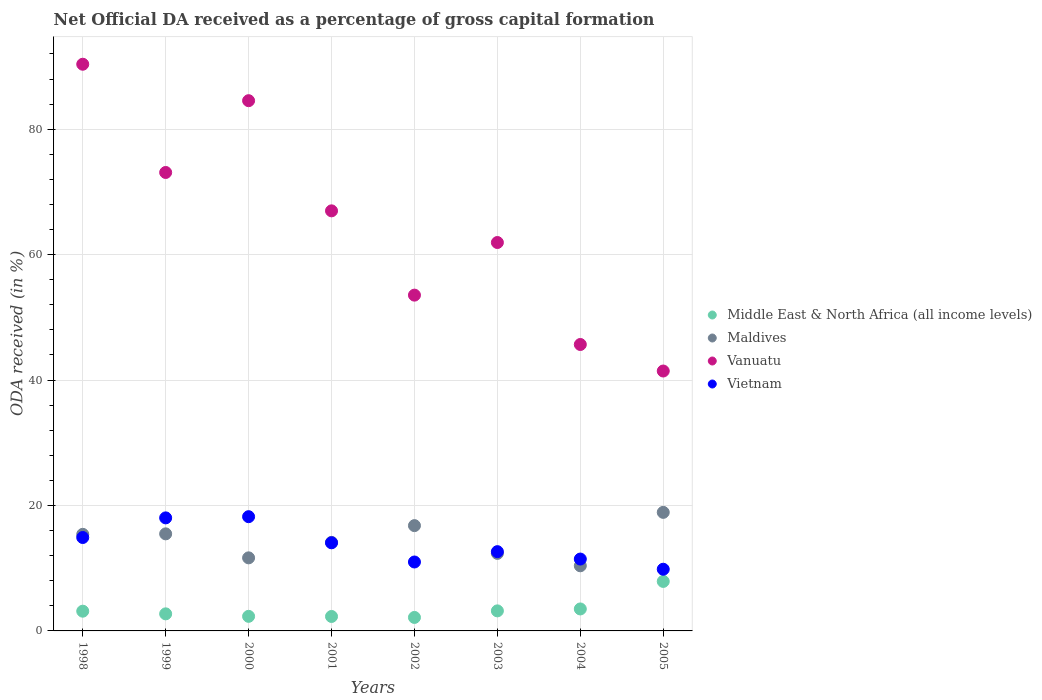Is the number of dotlines equal to the number of legend labels?
Provide a succinct answer. Yes. What is the net ODA received in Maldives in 2001?
Provide a succinct answer. 14.12. Across all years, what is the maximum net ODA received in Middle East & North Africa (all income levels)?
Your response must be concise. 7.89. Across all years, what is the minimum net ODA received in Vietnam?
Provide a short and direct response. 9.84. In which year was the net ODA received in Middle East & North Africa (all income levels) minimum?
Give a very brief answer. 2002. What is the total net ODA received in Maldives in the graph?
Keep it short and to the point. 115.09. What is the difference between the net ODA received in Vietnam in 2003 and that in 2004?
Provide a succinct answer. 1.18. What is the difference between the net ODA received in Middle East & North Africa (all income levels) in 2001 and the net ODA received in Maldives in 2005?
Your answer should be very brief. -16.6. What is the average net ODA received in Vietnam per year?
Make the answer very short. 13.76. In the year 2003, what is the difference between the net ODA received in Maldives and net ODA received in Vietnam?
Provide a succinct answer. -0.27. What is the ratio of the net ODA received in Vietnam in 1999 to that in 2005?
Keep it short and to the point. 1.83. Is the net ODA received in Maldives in 2000 less than that in 2005?
Provide a short and direct response. Yes. Is the difference between the net ODA received in Maldives in 2003 and 2005 greater than the difference between the net ODA received in Vietnam in 2003 and 2005?
Keep it short and to the point. No. What is the difference between the highest and the second highest net ODA received in Vietnam?
Offer a terse response. 0.19. What is the difference between the highest and the lowest net ODA received in Middle East & North Africa (all income levels)?
Make the answer very short. 5.74. In how many years, is the net ODA received in Maldives greater than the average net ODA received in Maldives taken over all years?
Your answer should be compact. 4. Is the sum of the net ODA received in Middle East & North Africa (all income levels) in 2001 and 2003 greater than the maximum net ODA received in Vanuatu across all years?
Your response must be concise. No. Is it the case that in every year, the sum of the net ODA received in Middle East & North Africa (all income levels) and net ODA received in Maldives  is greater than the sum of net ODA received in Vanuatu and net ODA received in Vietnam?
Offer a terse response. No. How many dotlines are there?
Provide a succinct answer. 4. How many years are there in the graph?
Provide a short and direct response. 8. Does the graph contain grids?
Your response must be concise. Yes. How are the legend labels stacked?
Offer a very short reply. Vertical. What is the title of the graph?
Offer a very short reply. Net Official DA received as a percentage of gross capital formation. Does "European Union" appear as one of the legend labels in the graph?
Keep it short and to the point. No. What is the label or title of the X-axis?
Make the answer very short. Years. What is the label or title of the Y-axis?
Make the answer very short. ODA received (in %). What is the ODA received (in %) in Middle East & North Africa (all income levels) in 1998?
Provide a short and direct response. 3.15. What is the ODA received (in %) of Maldives in 1998?
Provide a succinct answer. 15.4. What is the ODA received (in %) of Vanuatu in 1998?
Ensure brevity in your answer.  90.36. What is the ODA received (in %) of Vietnam in 1998?
Offer a very short reply. 14.89. What is the ODA received (in %) in Middle East & North Africa (all income levels) in 1999?
Your answer should be very brief. 2.72. What is the ODA received (in %) in Maldives in 1999?
Make the answer very short. 15.48. What is the ODA received (in %) of Vanuatu in 1999?
Provide a succinct answer. 73.1. What is the ODA received (in %) in Vietnam in 1999?
Your answer should be very brief. 18.03. What is the ODA received (in %) of Middle East & North Africa (all income levels) in 2000?
Provide a short and direct response. 2.32. What is the ODA received (in %) in Maldives in 2000?
Your answer should be compact. 11.65. What is the ODA received (in %) of Vanuatu in 2000?
Give a very brief answer. 84.55. What is the ODA received (in %) in Vietnam in 2000?
Offer a very short reply. 18.22. What is the ODA received (in %) in Middle East & North Africa (all income levels) in 2001?
Offer a terse response. 2.3. What is the ODA received (in %) in Maldives in 2001?
Your answer should be compact. 14.12. What is the ODA received (in %) of Vanuatu in 2001?
Give a very brief answer. 66.98. What is the ODA received (in %) of Vietnam in 2001?
Ensure brevity in your answer.  14.05. What is the ODA received (in %) in Middle East & North Africa (all income levels) in 2002?
Your answer should be very brief. 2.15. What is the ODA received (in %) in Maldives in 2002?
Offer a very short reply. 16.79. What is the ODA received (in %) in Vanuatu in 2002?
Give a very brief answer. 53.54. What is the ODA received (in %) of Vietnam in 2002?
Offer a terse response. 10.99. What is the ODA received (in %) in Middle East & North Africa (all income levels) in 2003?
Your answer should be compact. 3.2. What is the ODA received (in %) of Maldives in 2003?
Your answer should be very brief. 12.36. What is the ODA received (in %) of Vanuatu in 2003?
Offer a very short reply. 61.93. What is the ODA received (in %) of Vietnam in 2003?
Provide a succinct answer. 12.64. What is the ODA received (in %) of Middle East & North Africa (all income levels) in 2004?
Offer a very short reply. 3.5. What is the ODA received (in %) in Maldives in 2004?
Provide a short and direct response. 10.39. What is the ODA received (in %) in Vanuatu in 2004?
Your answer should be compact. 45.67. What is the ODA received (in %) of Vietnam in 2004?
Give a very brief answer. 11.46. What is the ODA received (in %) in Middle East & North Africa (all income levels) in 2005?
Your response must be concise. 7.89. What is the ODA received (in %) in Maldives in 2005?
Ensure brevity in your answer.  18.9. What is the ODA received (in %) in Vanuatu in 2005?
Provide a succinct answer. 41.44. What is the ODA received (in %) of Vietnam in 2005?
Offer a terse response. 9.84. Across all years, what is the maximum ODA received (in %) in Middle East & North Africa (all income levels)?
Give a very brief answer. 7.89. Across all years, what is the maximum ODA received (in %) of Maldives?
Make the answer very short. 18.9. Across all years, what is the maximum ODA received (in %) in Vanuatu?
Your answer should be compact. 90.36. Across all years, what is the maximum ODA received (in %) of Vietnam?
Ensure brevity in your answer.  18.22. Across all years, what is the minimum ODA received (in %) in Middle East & North Africa (all income levels)?
Your answer should be very brief. 2.15. Across all years, what is the minimum ODA received (in %) of Maldives?
Your answer should be compact. 10.39. Across all years, what is the minimum ODA received (in %) in Vanuatu?
Your answer should be very brief. 41.44. Across all years, what is the minimum ODA received (in %) in Vietnam?
Provide a succinct answer. 9.84. What is the total ODA received (in %) of Middle East & North Africa (all income levels) in the graph?
Your answer should be very brief. 27.24. What is the total ODA received (in %) of Maldives in the graph?
Provide a short and direct response. 115.09. What is the total ODA received (in %) of Vanuatu in the graph?
Make the answer very short. 517.6. What is the total ODA received (in %) in Vietnam in the graph?
Provide a short and direct response. 110.11. What is the difference between the ODA received (in %) in Middle East & North Africa (all income levels) in 1998 and that in 1999?
Offer a very short reply. 0.42. What is the difference between the ODA received (in %) in Maldives in 1998 and that in 1999?
Keep it short and to the point. -0.08. What is the difference between the ODA received (in %) in Vanuatu in 1998 and that in 1999?
Offer a very short reply. 17.26. What is the difference between the ODA received (in %) of Vietnam in 1998 and that in 1999?
Offer a very short reply. -3.13. What is the difference between the ODA received (in %) in Middle East & North Africa (all income levels) in 1998 and that in 2000?
Provide a short and direct response. 0.82. What is the difference between the ODA received (in %) of Maldives in 1998 and that in 2000?
Provide a succinct answer. 3.75. What is the difference between the ODA received (in %) of Vanuatu in 1998 and that in 2000?
Give a very brief answer. 5.81. What is the difference between the ODA received (in %) in Vietnam in 1998 and that in 2000?
Your answer should be very brief. -3.32. What is the difference between the ODA received (in %) in Middle East & North Africa (all income levels) in 1998 and that in 2001?
Offer a terse response. 0.84. What is the difference between the ODA received (in %) in Maldives in 1998 and that in 2001?
Give a very brief answer. 1.28. What is the difference between the ODA received (in %) of Vanuatu in 1998 and that in 2001?
Ensure brevity in your answer.  23.38. What is the difference between the ODA received (in %) in Vietnam in 1998 and that in 2001?
Provide a short and direct response. 0.84. What is the difference between the ODA received (in %) of Maldives in 1998 and that in 2002?
Your answer should be very brief. -1.39. What is the difference between the ODA received (in %) of Vanuatu in 1998 and that in 2002?
Provide a short and direct response. 36.82. What is the difference between the ODA received (in %) of Vietnam in 1998 and that in 2002?
Ensure brevity in your answer.  3.9. What is the difference between the ODA received (in %) in Middle East & North Africa (all income levels) in 1998 and that in 2003?
Your answer should be compact. -0.05. What is the difference between the ODA received (in %) in Maldives in 1998 and that in 2003?
Your answer should be compact. 3.04. What is the difference between the ODA received (in %) of Vanuatu in 1998 and that in 2003?
Your answer should be compact. 28.43. What is the difference between the ODA received (in %) in Vietnam in 1998 and that in 2003?
Offer a very short reply. 2.26. What is the difference between the ODA received (in %) of Middle East & North Africa (all income levels) in 1998 and that in 2004?
Offer a terse response. -0.36. What is the difference between the ODA received (in %) of Maldives in 1998 and that in 2004?
Offer a very short reply. 5.02. What is the difference between the ODA received (in %) of Vanuatu in 1998 and that in 2004?
Keep it short and to the point. 44.69. What is the difference between the ODA received (in %) in Vietnam in 1998 and that in 2004?
Provide a succinct answer. 3.43. What is the difference between the ODA received (in %) in Middle East & North Africa (all income levels) in 1998 and that in 2005?
Offer a very short reply. -4.75. What is the difference between the ODA received (in %) of Maldives in 1998 and that in 2005?
Your answer should be compact. -3.5. What is the difference between the ODA received (in %) of Vanuatu in 1998 and that in 2005?
Give a very brief answer. 48.92. What is the difference between the ODA received (in %) of Vietnam in 1998 and that in 2005?
Your answer should be very brief. 5.06. What is the difference between the ODA received (in %) in Middle East & North Africa (all income levels) in 1999 and that in 2000?
Provide a succinct answer. 0.4. What is the difference between the ODA received (in %) of Maldives in 1999 and that in 2000?
Provide a short and direct response. 3.83. What is the difference between the ODA received (in %) of Vanuatu in 1999 and that in 2000?
Provide a short and direct response. -11.45. What is the difference between the ODA received (in %) in Vietnam in 1999 and that in 2000?
Keep it short and to the point. -0.19. What is the difference between the ODA received (in %) in Middle East & North Africa (all income levels) in 1999 and that in 2001?
Keep it short and to the point. 0.42. What is the difference between the ODA received (in %) in Maldives in 1999 and that in 2001?
Provide a succinct answer. 1.36. What is the difference between the ODA received (in %) of Vanuatu in 1999 and that in 2001?
Your response must be concise. 6.12. What is the difference between the ODA received (in %) of Vietnam in 1999 and that in 2001?
Your response must be concise. 3.97. What is the difference between the ODA received (in %) in Middle East & North Africa (all income levels) in 1999 and that in 2002?
Ensure brevity in your answer.  0.57. What is the difference between the ODA received (in %) of Maldives in 1999 and that in 2002?
Ensure brevity in your answer.  -1.31. What is the difference between the ODA received (in %) of Vanuatu in 1999 and that in 2002?
Offer a very short reply. 19.56. What is the difference between the ODA received (in %) of Vietnam in 1999 and that in 2002?
Your response must be concise. 7.04. What is the difference between the ODA received (in %) in Middle East & North Africa (all income levels) in 1999 and that in 2003?
Keep it short and to the point. -0.48. What is the difference between the ODA received (in %) of Maldives in 1999 and that in 2003?
Keep it short and to the point. 3.11. What is the difference between the ODA received (in %) of Vanuatu in 1999 and that in 2003?
Your response must be concise. 11.17. What is the difference between the ODA received (in %) in Vietnam in 1999 and that in 2003?
Your response must be concise. 5.39. What is the difference between the ODA received (in %) in Middle East & North Africa (all income levels) in 1999 and that in 2004?
Provide a short and direct response. -0.78. What is the difference between the ODA received (in %) of Maldives in 1999 and that in 2004?
Your response must be concise. 5.09. What is the difference between the ODA received (in %) in Vanuatu in 1999 and that in 2004?
Make the answer very short. 27.43. What is the difference between the ODA received (in %) of Vietnam in 1999 and that in 2004?
Provide a succinct answer. 6.57. What is the difference between the ODA received (in %) in Middle East & North Africa (all income levels) in 1999 and that in 2005?
Your response must be concise. -5.17. What is the difference between the ODA received (in %) of Maldives in 1999 and that in 2005?
Give a very brief answer. -3.43. What is the difference between the ODA received (in %) of Vanuatu in 1999 and that in 2005?
Keep it short and to the point. 31.66. What is the difference between the ODA received (in %) in Vietnam in 1999 and that in 2005?
Provide a succinct answer. 8.19. What is the difference between the ODA received (in %) in Middle East & North Africa (all income levels) in 2000 and that in 2001?
Ensure brevity in your answer.  0.02. What is the difference between the ODA received (in %) of Maldives in 2000 and that in 2001?
Your answer should be compact. -2.46. What is the difference between the ODA received (in %) of Vanuatu in 2000 and that in 2001?
Offer a terse response. 17.57. What is the difference between the ODA received (in %) in Vietnam in 2000 and that in 2001?
Keep it short and to the point. 4.16. What is the difference between the ODA received (in %) of Middle East & North Africa (all income levels) in 2000 and that in 2002?
Offer a very short reply. 0.17. What is the difference between the ODA received (in %) of Maldives in 2000 and that in 2002?
Your answer should be very brief. -5.14. What is the difference between the ODA received (in %) of Vanuatu in 2000 and that in 2002?
Your answer should be compact. 31.01. What is the difference between the ODA received (in %) in Vietnam in 2000 and that in 2002?
Keep it short and to the point. 7.23. What is the difference between the ODA received (in %) in Middle East & North Africa (all income levels) in 2000 and that in 2003?
Offer a very short reply. -0.87. What is the difference between the ODA received (in %) of Maldives in 2000 and that in 2003?
Keep it short and to the point. -0.71. What is the difference between the ODA received (in %) in Vanuatu in 2000 and that in 2003?
Ensure brevity in your answer.  22.62. What is the difference between the ODA received (in %) of Vietnam in 2000 and that in 2003?
Your answer should be very brief. 5.58. What is the difference between the ODA received (in %) in Middle East & North Africa (all income levels) in 2000 and that in 2004?
Provide a succinct answer. -1.18. What is the difference between the ODA received (in %) of Maldives in 2000 and that in 2004?
Offer a very short reply. 1.27. What is the difference between the ODA received (in %) of Vanuatu in 2000 and that in 2004?
Make the answer very short. 38.88. What is the difference between the ODA received (in %) in Vietnam in 2000 and that in 2004?
Offer a terse response. 6.76. What is the difference between the ODA received (in %) of Middle East & North Africa (all income levels) in 2000 and that in 2005?
Provide a succinct answer. -5.57. What is the difference between the ODA received (in %) of Maldives in 2000 and that in 2005?
Your response must be concise. -7.25. What is the difference between the ODA received (in %) of Vanuatu in 2000 and that in 2005?
Give a very brief answer. 43.11. What is the difference between the ODA received (in %) in Vietnam in 2000 and that in 2005?
Provide a succinct answer. 8.38. What is the difference between the ODA received (in %) of Middle East & North Africa (all income levels) in 2001 and that in 2002?
Provide a succinct answer. 0.15. What is the difference between the ODA received (in %) of Maldives in 2001 and that in 2002?
Make the answer very short. -2.67. What is the difference between the ODA received (in %) of Vanuatu in 2001 and that in 2002?
Your answer should be very brief. 13.44. What is the difference between the ODA received (in %) in Vietnam in 2001 and that in 2002?
Provide a short and direct response. 3.06. What is the difference between the ODA received (in %) of Middle East & North Africa (all income levels) in 2001 and that in 2003?
Your answer should be very brief. -0.89. What is the difference between the ODA received (in %) in Maldives in 2001 and that in 2003?
Ensure brevity in your answer.  1.75. What is the difference between the ODA received (in %) in Vanuatu in 2001 and that in 2003?
Provide a short and direct response. 5.05. What is the difference between the ODA received (in %) in Vietnam in 2001 and that in 2003?
Provide a short and direct response. 1.42. What is the difference between the ODA received (in %) of Middle East & North Africa (all income levels) in 2001 and that in 2004?
Your answer should be compact. -1.2. What is the difference between the ODA received (in %) in Maldives in 2001 and that in 2004?
Your response must be concise. 3.73. What is the difference between the ODA received (in %) of Vanuatu in 2001 and that in 2004?
Give a very brief answer. 21.31. What is the difference between the ODA received (in %) of Vietnam in 2001 and that in 2004?
Keep it short and to the point. 2.59. What is the difference between the ODA received (in %) in Middle East & North Africa (all income levels) in 2001 and that in 2005?
Your answer should be very brief. -5.59. What is the difference between the ODA received (in %) in Maldives in 2001 and that in 2005?
Ensure brevity in your answer.  -4.79. What is the difference between the ODA received (in %) in Vanuatu in 2001 and that in 2005?
Your answer should be compact. 25.54. What is the difference between the ODA received (in %) of Vietnam in 2001 and that in 2005?
Give a very brief answer. 4.22. What is the difference between the ODA received (in %) in Middle East & North Africa (all income levels) in 2002 and that in 2003?
Keep it short and to the point. -1.05. What is the difference between the ODA received (in %) of Maldives in 2002 and that in 2003?
Offer a terse response. 4.43. What is the difference between the ODA received (in %) in Vanuatu in 2002 and that in 2003?
Your response must be concise. -8.39. What is the difference between the ODA received (in %) in Vietnam in 2002 and that in 2003?
Provide a succinct answer. -1.65. What is the difference between the ODA received (in %) of Middle East & North Africa (all income levels) in 2002 and that in 2004?
Your answer should be very brief. -1.35. What is the difference between the ODA received (in %) in Maldives in 2002 and that in 2004?
Ensure brevity in your answer.  6.41. What is the difference between the ODA received (in %) in Vanuatu in 2002 and that in 2004?
Give a very brief answer. 7.87. What is the difference between the ODA received (in %) of Vietnam in 2002 and that in 2004?
Provide a short and direct response. -0.47. What is the difference between the ODA received (in %) in Middle East & North Africa (all income levels) in 2002 and that in 2005?
Offer a very short reply. -5.74. What is the difference between the ODA received (in %) of Maldives in 2002 and that in 2005?
Offer a terse response. -2.11. What is the difference between the ODA received (in %) of Vanuatu in 2002 and that in 2005?
Provide a succinct answer. 12.1. What is the difference between the ODA received (in %) in Vietnam in 2002 and that in 2005?
Offer a very short reply. 1.16. What is the difference between the ODA received (in %) of Middle East & North Africa (all income levels) in 2003 and that in 2004?
Offer a terse response. -0.31. What is the difference between the ODA received (in %) in Maldives in 2003 and that in 2004?
Make the answer very short. 1.98. What is the difference between the ODA received (in %) in Vanuatu in 2003 and that in 2004?
Keep it short and to the point. 16.26. What is the difference between the ODA received (in %) of Vietnam in 2003 and that in 2004?
Your answer should be compact. 1.18. What is the difference between the ODA received (in %) in Middle East & North Africa (all income levels) in 2003 and that in 2005?
Provide a succinct answer. -4.7. What is the difference between the ODA received (in %) in Maldives in 2003 and that in 2005?
Make the answer very short. -6.54. What is the difference between the ODA received (in %) of Vanuatu in 2003 and that in 2005?
Make the answer very short. 20.49. What is the difference between the ODA received (in %) of Vietnam in 2003 and that in 2005?
Offer a very short reply. 2.8. What is the difference between the ODA received (in %) of Middle East & North Africa (all income levels) in 2004 and that in 2005?
Offer a very short reply. -4.39. What is the difference between the ODA received (in %) in Maldives in 2004 and that in 2005?
Your response must be concise. -8.52. What is the difference between the ODA received (in %) of Vanuatu in 2004 and that in 2005?
Keep it short and to the point. 4.23. What is the difference between the ODA received (in %) in Vietnam in 2004 and that in 2005?
Your answer should be very brief. 1.62. What is the difference between the ODA received (in %) in Middle East & North Africa (all income levels) in 1998 and the ODA received (in %) in Maldives in 1999?
Keep it short and to the point. -12.33. What is the difference between the ODA received (in %) in Middle East & North Africa (all income levels) in 1998 and the ODA received (in %) in Vanuatu in 1999?
Offer a terse response. -69.96. What is the difference between the ODA received (in %) in Middle East & North Africa (all income levels) in 1998 and the ODA received (in %) in Vietnam in 1999?
Keep it short and to the point. -14.88. What is the difference between the ODA received (in %) of Maldives in 1998 and the ODA received (in %) of Vanuatu in 1999?
Ensure brevity in your answer.  -57.7. What is the difference between the ODA received (in %) in Maldives in 1998 and the ODA received (in %) in Vietnam in 1999?
Your answer should be compact. -2.62. What is the difference between the ODA received (in %) of Vanuatu in 1998 and the ODA received (in %) of Vietnam in 1999?
Give a very brief answer. 72.34. What is the difference between the ODA received (in %) in Middle East & North Africa (all income levels) in 1998 and the ODA received (in %) in Maldives in 2000?
Your response must be concise. -8.51. What is the difference between the ODA received (in %) of Middle East & North Africa (all income levels) in 1998 and the ODA received (in %) of Vanuatu in 2000?
Give a very brief answer. -81.4. What is the difference between the ODA received (in %) in Middle East & North Africa (all income levels) in 1998 and the ODA received (in %) in Vietnam in 2000?
Your answer should be compact. -15.07. What is the difference between the ODA received (in %) in Maldives in 1998 and the ODA received (in %) in Vanuatu in 2000?
Your answer should be compact. -69.15. What is the difference between the ODA received (in %) in Maldives in 1998 and the ODA received (in %) in Vietnam in 2000?
Keep it short and to the point. -2.81. What is the difference between the ODA received (in %) of Vanuatu in 1998 and the ODA received (in %) of Vietnam in 2000?
Give a very brief answer. 72.15. What is the difference between the ODA received (in %) of Middle East & North Africa (all income levels) in 1998 and the ODA received (in %) of Maldives in 2001?
Provide a short and direct response. -10.97. What is the difference between the ODA received (in %) of Middle East & North Africa (all income levels) in 1998 and the ODA received (in %) of Vanuatu in 2001?
Your answer should be compact. -63.84. What is the difference between the ODA received (in %) of Middle East & North Africa (all income levels) in 1998 and the ODA received (in %) of Vietnam in 2001?
Offer a terse response. -10.91. What is the difference between the ODA received (in %) in Maldives in 1998 and the ODA received (in %) in Vanuatu in 2001?
Provide a succinct answer. -51.58. What is the difference between the ODA received (in %) in Maldives in 1998 and the ODA received (in %) in Vietnam in 2001?
Make the answer very short. 1.35. What is the difference between the ODA received (in %) in Vanuatu in 1998 and the ODA received (in %) in Vietnam in 2001?
Offer a very short reply. 76.31. What is the difference between the ODA received (in %) of Middle East & North Africa (all income levels) in 1998 and the ODA received (in %) of Maldives in 2002?
Make the answer very short. -13.64. What is the difference between the ODA received (in %) of Middle East & North Africa (all income levels) in 1998 and the ODA received (in %) of Vanuatu in 2002?
Provide a short and direct response. -50.4. What is the difference between the ODA received (in %) of Middle East & North Africa (all income levels) in 1998 and the ODA received (in %) of Vietnam in 2002?
Provide a short and direct response. -7.84. What is the difference between the ODA received (in %) of Maldives in 1998 and the ODA received (in %) of Vanuatu in 2002?
Ensure brevity in your answer.  -38.14. What is the difference between the ODA received (in %) of Maldives in 1998 and the ODA received (in %) of Vietnam in 2002?
Offer a terse response. 4.41. What is the difference between the ODA received (in %) of Vanuatu in 1998 and the ODA received (in %) of Vietnam in 2002?
Provide a succinct answer. 79.37. What is the difference between the ODA received (in %) of Middle East & North Africa (all income levels) in 1998 and the ODA received (in %) of Maldives in 2003?
Provide a succinct answer. -9.22. What is the difference between the ODA received (in %) of Middle East & North Africa (all income levels) in 1998 and the ODA received (in %) of Vanuatu in 2003?
Offer a very short reply. -58.79. What is the difference between the ODA received (in %) of Middle East & North Africa (all income levels) in 1998 and the ODA received (in %) of Vietnam in 2003?
Provide a short and direct response. -9.49. What is the difference between the ODA received (in %) in Maldives in 1998 and the ODA received (in %) in Vanuatu in 2003?
Provide a short and direct response. -46.53. What is the difference between the ODA received (in %) in Maldives in 1998 and the ODA received (in %) in Vietnam in 2003?
Keep it short and to the point. 2.76. What is the difference between the ODA received (in %) of Vanuatu in 1998 and the ODA received (in %) of Vietnam in 2003?
Give a very brief answer. 77.72. What is the difference between the ODA received (in %) in Middle East & North Africa (all income levels) in 1998 and the ODA received (in %) in Maldives in 2004?
Offer a terse response. -7.24. What is the difference between the ODA received (in %) in Middle East & North Africa (all income levels) in 1998 and the ODA received (in %) in Vanuatu in 2004?
Your answer should be compact. -42.53. What is the difference between the ODA received (in %) in Middle East & North Africa (all income levels) in 1998 and the ODA received (in %) in Vietnam in 2004?
Offer a very short reply. -8.31. What is the difference between the ODA received (in %) of Maldives in 1998 and the ODA received (in %) of Vanuatu in 2004?
Your answer should be very brief. -30.27. What is the difference between the ODA received (in %) in Maldives in 1998 and the ODA received (in %) in Vietnam in 2004?
Provide a short and direct response. 3.94. What is the difference between the ODA received (in %) in Vanuatu in 1998 and the ODA received (in %) in Vietnam in 2004?
Offer a very short reply. 78.9. What is the difference between the ODA received (in %) in Middle East & North Africa (all income levels) in 1998 and the ODA received (in %) in Maldives in 2005?
Your response must be concise. -15.76. What is the difference between the ODA received (in %) in Middle East & North Africa (all income levels) in 1998 and the ODA received (in %) in Vanuatu in 2005?
Make the answer very short. -38.3. What is the difference between the ODA received (in %) in Middle East & North Africa (all income levels) in 1998 and the ODA received (in %) in Vietnam in 2005?
Provide a short and direct response. -6.69. What is the difference between the ODA received (in %) in Maldives in 1998 and the ODA received (in %) in Vanuatu in 2005?
Offer a very short reply. -26.04. What is the difference between the ODA received (in %) in Maldives in 1998 and the ODA received (in %) in Vietnam in 2005?
Provide a succinct answer. 5.57. What is the difference between the ODA received (in %) of Vanuatu in 1998 and the ODA received (in %) of Vietnam in 2005?
Offer a terse response. 80.53. What is the difference between the ODA received (in %) in Middle East & North Africa (all income levels) in 1999 and the ODA received (in %) in Maldives in 2000?
Provide a succinct answer. -8.93. What is the difference between the ODA received (in %) of Middle East & North Africa (all income levels) in 1999 and the ODA received (in %) of Vanuatu in 2000?
Your answer should be very brief. -81.83. What is the difference between the ODA received (in %) of Middle East & North Africa (all income levels) in 1999 and the ODA received (in %) of Vietnam in 2000?
Your answer should be compact. -15.49. What is the difference between the ODA received (in %) in Maldives in 1999 and the ODA received (in %) in Vanuatu in 2000?
Provide a succinct answer. -69.07. What is the difference between the ODA received (in %) of Maldives in 1999 and the ODA received (in %) of Vietnam in 2000?
Provide a short and direct response. -2.74. What is the difference between the ODA received (in %) of Vanuatu in 1999 and the ODA received (in %) of Vietnam in 2000?
Ensure brevity in your answer.  54.89. What is the difference between the ODA received (in %) of Middle East & North Africa (all income levels) in 1999 and the ODA received (in %) of Maldives in 2001?
Your answer should be very brief. -11.39. What is the difference between the ODA received (in %) of Middle East & North Africa (all income levels) in 1999 and the ODA received (in %) of Vanuatu in 2001?
Give a very brief answer. -64.26. What is the difference between the ODA received (in %) in Middle East & North Africa (all income levels) in 1999 and the ODA received (in %) in Vietnam in 2001?
Your response must be concise. -11.33. What is the difference between the ODA received (in %) of Maldives in 1999 and the ODA received (in %) of Vanuatu in 2001?
Give a very brief answer. -51.51. What is the difference between the ODA received (in %) of Maldives in 1999 and the ODA received (in %) of Vietnam in 2001?
Your response must be concise. 1.42. What is the difference between the ODA received (in %) in Vanuatu in 1999 and the ODA received (in %) in Vietnam in 2001?
Your answer should be compact. 59.05. What is the difference between the ODA received (in %) in Middle East & North Africa (all income levels) in 1999 and the ODA received (in %) in Maldives in 2002?
Provide a succinct answer. -14.07. What is the difference between the ODA received (in %) in Middle East & North Africa (all income levels) in 1999 and the ODA received (in %) in Vanuatu in 2002?
Offer a very short reply. -50.82. What is the difference between the ODA received (in %) of Middle East & North Africa (all income levels) in 1999 and the ODA received (in %) of Vietnam in 2002?
Make the answer very short. -8.27. What is the difference between the ODA received (in %) in Maldives in 1999 and the ODA received (in %) in Vanuatu in 2002?
Ensure brevity in your answer.  -38.07. What is the difference between the ODA received (in %) of Maldives in 1999 and the ODA received (in %) of Vietnam in 2002?
Keep it short and to the point. 4.49. What is the difference between the ODA received (in %) in Vanuatu in 1999 and the ODA received (in %) in Vietnam in 2002?
Offer a very short reply. 62.11. What is the difference between the ODA received (in %) of Middle East & North Africa (all income levels) in 1999 and the ODA received (in %) of Maldives in 2003?
Keep it short and to the point. -9.64. What is the difference between the ODA received (in %) in Middle East & North Africa (all income levels) in 1999 and the ODA received (in %) in Vanuatu in 2003?
Provide a succinct answer. -59.21. What is the difference between the ODA received (in %) of Middle East & North Africa (all income levels) in 1999 and the ODA received (in %) of Vietnam in 2003?
Ensure brevity in your answer.  -9.92. What is the difference between the ODA received (in %) in Maldives in 1999 and the ODA received (in %) in Vanuatu in 2003?
Your answer should be compact. -46.46. What is the difference between the ODA received (in %) in Maldives in 1999 and the ODA received (in %) in Vietnam in 2003?
Offer a terse response. 2.84. What is the difference between the ODA received (in %) in Vanuatu in 1999 and the ODA received (in %) in Vietnam in 2003?
Your answer should be very brief. 60.46. What is the difference between the ODA received (in %) in Middle East & North Africa (all income levels) in 1999 and the ODA received (in %) in Maldives in 2004?
Give a very brief answer. -7.66. What is the difference between the ODA received (in %) of Middle East & North Africa (all income levels) in 1999 and the ODA received (in %) of Vanuatu in 2004?
Offer a very short reply. -42.95. What is the difference between the ODA received (in %) in Middle East & North Africa (all income levels) in 1999 and the ODA received (in %) in Vietnam in 2004?
Offer a very short reply. -8.74. What is the difference between the ODA received (in %) in Maldives in 1999 and the ODA received (in %) in Vanuatu in 2004?
Give a very brief answer. -30.2. What is the difference between the ODA received (in %) in Maldives in 1999 and the ODA received (in %) in Vietnam in 2004?
Your answer should be very brief. 4.02. What is the difference between the ODA received (in %) in Vanuatu in 1999 and the ODA received (in %) in Vietnam in 2004?
Offer a very short reply. 61.64. What is the difference between the ODA received (in %) of Middle East & North Africa (all income levels) in 1999 and the ODA received (in %) of Maldives in 2005?
Offer a very short reply. -16.18. What is the difference between the ODA received (in %) of Middle East & North Africa (all income levels) in 1999 and the ODA received (in %) of Vanuatu in 2005?
Provide a short and direct response. -38.72. What is the difference between the ODA received (in %) in Middle East & North Africa (all income levels) in 1999 and the ODA received (in %) in Vietnam in 2005?
Ensure brevity in your answer.  -7.11. What is the difference between the ODA received (in %) of Maldives in 1999 and the ODA received (in %) of Vanuatu in 2005?
Keep it short and to the point. -25.97. What is the difference between the ODA received (in %) in Maldives in 1999 and the ODA received (in %) in Vietnam in 2005?
Ensure brevity in your answer.  5.64. What is the difference between the ODA received (in %) in Vanuatu in 1999 and the ODA received (in %) in Vietnam in 2005?
Provide a succinct answer. 63.27. What is the difference between the ODA received (in %) of Middle East & North Africa (all income levels) in 2000 and the ODA received (in %) of Maldives in 2001?
Your response must be concise. -11.79. What is the difference between the ODA received (in %) of Middle East & North Africa (all income levels) in 2000 and the ODA received (in %) of Vanuatu in 2001?
Provide a succinct answer. -64.66. What is the difference between the ODA received (in %) in Middle East & North Africa (all income levels) in 2000 and the ODA received (in %) in Vietnam in 2001?
Offer a terse response. -11.73. What is the difference between the ODA received (in %) in Maldives in 2000 and the ODA received (in %) in Vanuatu in 2001?
Your answer should be compact. -55.33. What is the difference between the ODA received (in %) in Maldives in 2000 and the ODA received (in %) in Vietnam in 2001?
Provide a short and direct response. -2.4. What is the difference between the ODA received (in %) of Vanuatu in 2000 and the ODA received (in %) of Vietnam in 2001?
Make the answer very short. 70.5. What is the difference between the ODA received (in %) in Middle East & North Africa (all income levels) in 2000 and the ODA received (in %) in Maldives in 2002?
Offer a very short reply. -14.47. What is the difference between the ODA received (in %) of Middle East & North Africa (all income levels) in 2000 and the ODA received (in %) of Vanuatu in 2002?
Your answer should be compact. -51.22. What is the difference between the ODA received (in %) in Middle East & North Africa (all income levels) in 2000 and the ODA received (in %) in Vietnam in 2002?
Provide a short and direct response. -8.67. What is the difference between the ODA received (in %) of Maldives in 2000 and the ODA received (in %) of Vanuatu in 2002?
Offer a very short reply. -41.89. What is the difference between the ODA received (in %) in Maldives in 2000 and the ODA received (in %) in Vietnam in 2002?
Ensure brevity in your answer.  0.66. What is the difference between the ODA received (in %) of Vanuatu in 2000 and the ODA received (in %) of Vietnam in 2002?
Provide a succinct answer. 73.56. What is the difference between the ODA received (in %) of Middle East & North Africa (all income levels) in 2000 and the ODA received (in %) of Maldives in 2003?
Provide a short and direct response. -10.04. What is the difference between the ODA received (in %) in Middle East & North Africa (all income levels) in 2000 and the ODA received (in %) in Vanuatu in 2003?
Provide a short and direct response. -59.61. What is the difference between the ODA received (in %) of Middle East & North Africa (all income levels) in 2000 and the ODA received (in %) of Vietnam in 2003?
Ensure brevity in your answer.  -10.31. What is the difference between the ODA received (in %) of Maldives in 2000 and the ODA received (in %) of Vanuatu in 2003?
Offer a terse response. -50.28. What is the difference between the ODA received (in %) in Maldives in 2000 and the ODA received (in %) in Vietnam in 2003?
Offer a terse response. -0.99. What is the difference between the ODA received (in %) of Vanuatu in 2000 and the ODA received (in %) of Vietnam in 2003?
Make the answer very short. 71.91. What is the difference between the ODA received (in %) in Middle East & North Africa (all income levels) in 2000 and the ODA received (in %) in Maldives in 2004?
Your answer should be compact. -8.06. What is the difference between the ODA received (in %) in Middle East & North Africa (all income levels) in 2000 and the ODA received (in %) in Vanuatu in 2004?
Provide a succinct answer. -43.35. What is the difference between the ODA received (in %) of Middle East & North Africa (all income levels) in 2000 and the ODA received (in %) of Vietnam in 2004?
Keep it short and to the point. -9.14. What is the difference between the ODA received (in %) of Maldives in 2000 and the ODA received (in %) of Vanuatu in 2004?
Keep it short and to the point. -34.02. What is the difference between the ODA received (in %) in Maldives in 2000 and the ODA received (in %) in Vietnam in 2004?
Provide a short and direct response. 0.19. What is the difference between the ODA received (in %) in Vanuatu in 2000 and the ODA received (in %) in Vietnam in 2004?
Offer a very short reply. 73.09. What is the difference between the ODA received (in %) in Middle East & North Africa (all income levels) in 2000 and the ODA received (in %) in Maldives in 2005?
Make the answer very short. -16.58. What is the difference between the ODA received (in %) in Middle East & North Africa (all income levels) in 2000 and the ODA received (in %) in Vanuatu in 2005?
Offer a terse response. -39.12. What is the difference between the ODA received (in %) in Middle East & North Africa (all income levels) in 2000 and the ODA received (in %) in Vietnam in 2005?
Make the answer very short. -7.51. What is the difference between the ODA received (in %) in Maldives in 2000 and the ODA received (in %) in Vanuatu in 2005?
Ensure brevity in your answer.  -29.79. What is the difference between the ODA received (in %) of Maldives in 2000 and the ODA received (in %) of Vietnam in 2005?
Ensure brevity in your answer.  1.82. What is the difference between the ODA received (in %) of Vanuatu in 2000 and the ODA received (in %) of Vietnam in 2005?
Ensure brevity in your answer.  74.72. What is the difference between the ODA received (in %) of Middle East & North Africa (all income levels) in 2001 and the ODA received (in %) of Maldives in 2002?
Provide a short and direct response. -14.49. What is the difference between the ODA received (in %) of Middle East & North Africa (all income levels) in 2001 and the ODA received (in %) of Vanuatu in 2002?
Ensure brevity in your answer.  -51.24. What is the difference between the ODA received (in %) in Middle East & North Africa (all income levels) in 2001 and the ODA received (in %) in Vietnam in 2002?
Your answer should be very brief. -8.69. What is the difference between the ODA received (in %) of Maldives in 2001 and the ODA received (in %) of Vanuatu in 2002?
Make the answer very short. -39.43. What is the difference between the ODA received (in %) in Maldives in 2001 and the ODA received (in %) in Vietnam in 2002?
Offer a terse response. 3.13. What is the difference between the ODA received (in %) in Vanuatu in 2001 and the ODA received (in %) in Vietnam in 2002?
Provide a succinct answer. 55.99. What is the difference between the ODA received (in %) in Middle East & North Africa (all income levels) in 2001 and the ODA received (in %) in Maldives in 2003?
Offer a very short reply. -10.06. What is the difference between the ODA received (in %) in Middle East & North Africa (all income levels) in 2001 and the ODA received (in %) in Vanuatu in 2003?
Offer a very short reply. -59.63. What is the difference between the ODA received (in %) in Middle East & North Africa (all income levels) in 2001 and the ODA received (in %) in Vietnam in 2003?
Your response must be concise. -10.33. What is the difference between the ODA received (in %) of Maldives in 2001 and the ODA received (in %) of Vanuatu in 2003?
Provide a succinct answer. -47.82. What is the difference between the ODA received (in %) in Maldives in 2001 and the ODA received (in %) in Vietnam in 2003?
Your response must be concise. 1.48. What is the difference between the ODA received (in %) of Vanuatu in 2001 and the ODA received (in %) of Vietnam in 2003?
Ensure brevity in your answer.  54.35. What is the difference between the ODA received (in %) in Middle East & North Africa (all income levels) in 2001 and the ODA received (in %) in Maldives in 2004?
Offer a very short reply. -8.08. What is the difference between the ODA received (in %) of Middle East & North Africa (all income levels) in 2001 and the ODA received (in %) of Vanuatu in 2004?
Provide a short and direct response. -43.37. What is the difference between the ODA received (in %) in Middle East & North Africa (all income levels) in 2001 and the ODA received (in %) in Vietnam in 2004?
Give a very brief answer. -9.16. What is the difference between the ODA received (in %) in Maldives in 2001 and the ODA received (in %) in Vanuatu in 2004?
Keep it short and to the point. -31.56. What is the difference between the ODA received (in %) of Maldives in 2001 and the ODA received (in %) of Vietnam in 2004?
Your answer should be compact. 2.66. What is the difference between the ODA received (in %) of Vanuatu in 2001 and the ODA received (in %) of Vietnam in 2004?
Offer a terse response. 55.52. What is the difference between the ODA received (in %) in Middle East & North Africa (all income levels) in 2001 and the ODA received (in %) in Maldives in 2005?
Your response must be concise. -16.6. What is the difference between the ODA received (in %) of Middle East & North Africa (all income levels) in 2001 and the ODA received (in %) of Vanuatu in 2005?
Your answer should be compact. -39.14. What is the difference between the ODA received (in %) in Middle East & North Africa (all income levels) in 2001 and the ODA received (in %) in Vietnam in 2005?
Make the answer very short. -7.53. What is the difference between the ODA received (in %) of Maldives in 2001 and the ODA received (in %) of Vanuatu in 2005?
Your response must be concise. -27.33. What is the difference between the ODA received (in %) of Maldives in 2001 and the ODA received (in %) of Vietnam in 2005?
Your response must be concise. 4.28. What is the difference between the ODA received (in %) of Vanuatu in 2001 and the ODA received (in %) of Vietnam in 2005?
Your answer should be very brief. 57.15. What is the difference between the ODA received (in %) in Middle East & North Africa (all income levels) in 2002 and the ODA received (in %) in Maldives in 2003?
Offer a terse response. -10.21. What is the difference between the ODA received (in %) of Middle East & North Africa (all income levels) in 2002 and the ODA received (in %) of Vanuatu in 2003?
Provide a short and direct response. -59.78. What is the difference between the ODA received (in %) in Middle East & North Africa (all income levels) in 2002 and the ODA received (in %) in Vietnam in 2003?
Your answer should be very brief. -10.49. What is the difference between the ODA received (in %) of Maldives in 2002 and the ODA received (in %) of Vanuatu in 2003?
Give a very brief answer. -45.14. What is the difference between the ODA received (in %) of Maldives in 2002 and the ODA received (in %) of Vietnam in 2003?
Keep it short and to the point. 4.15. What is the difference between the ODA received (in %) of Vanuatu in 2002 and the ODA received (in %) of Vietnam in 2003?
Your answer should be very brief. 40.9. What is the difference between the ODA received (in %) of Middle East & North Africa (all income levels) in 2002 and the ODA received (in %) of Maldives in 2004?
Provide a succinct answer. -8.23. What is the difference between the ODA received (in %) in Middle East & North Africa (all income levels) in 2002 and the ODA received (in %) in Vanuatu in 2004?
Offer a very short reply. -43.52. What is the difference between the ODA received (in %) of Middle East & North Africa (all income levels) in 2002 and the ODA received (in %) of Vietnam in 2004?
Your response must be concise. -9.31. What is the difference between the ODA received (in %) in Maldives in 2002 and the ODA received (in %) in Vanuatu in 2004?
Your answer should be very brief. -28.88. What is the difference between the ODA received (in %) in Maldives in 2002 and the ODA received (in %) in Vietnam in 2004?
Offer a terse response. 5.33. What is the difference between the ODA received (in %) of Vanuatu in 2002 and the ODA received (in %) of Vietnam in 2004?
Offer a terse response. 42.08. What is the difference between the ODA received (in %) in Middle East & North Africa (all income levels) in 2002 and the ODA received (in %) in Maldives in 2005?
Provide a short and direct response. -16.75. What is the difference between the ODA received (in %) in Middle East & North Africa (all income levels) in 2002 and the ODA received (in %) in Vanuatu in 2005?
Keep it short and to the point. -39.29. What is the difference between the ODA received (in %) of Middle East & North Africa (all income levels) in 2002 and the ODA received (in %) of Vietnam in 2005?
Provide a short and direct response. -7.68. What is the difference between the ODA received (in %) in Maldives in 2002 and the ODA received (in %) in Vanuatu in 2005?
Provide a succinct answer. -24.65. What is the difference between the ODA received (in %) in Maldives in 2002 and the ODA received (in %) in Vietnam in 2005?
Make the answer very short. 6.96. What is the difference between the ODA received (in %) in Vanuatu in 2002 and the ODA received (in %) in Vietnam in 2005?
Your response must be concise. 43.71. What is the difference between the ODA received (in %) in Middle East & North Africa (all income levels) in 2003 and the ODA received (in %) in Maldives in 2004?
Make the answer very short. -7.19. What is the difference between the ODA received (in %) of Middle East & North Africa (all income levels) in 2003 and the ODA received (in %) of Vanuatu in 2004?
Offer a very short reply. -42.48. What is the difference between the ODA received (in %) of Middle East & North Africa (all income levels) in 2003 and the ODA received (in %) of Vietnam in 2004?
Ensure brevity in your answer.  -8.26. What is the difference between the ODA received (in %) of Maldives in 2003 and the ODA received (in %) of Vanuatu in 2004?
Your response must be concise. -33.31. What is the difference between the ODA received (in %) in Maldives in 2003 and the ODA received (in %) in Vietnam in 2004?
Your response must be concise. 0.9. What is the difference between the ODA received (in %) in Vanuatu in 2003 and the ODA received (in %) in Vietnam in 2004?
Make the answer very short. 50.47. What is the difference between the ODA received (in %) of Middle East & North Africa (all income levels) in 2003 and the ODA received (in %) of Maldives in 2005?
Your answer should be compact. -15.71. What is the difference between the ODA received (in %) in Middle East & North Africa (all income levels) in 2003 and the ODA received (in %) in Vanuatu in 2005?
Give a very brief answer. -38.25. What is the difference between the ODA received (in %) of Middle East & North Africa (all income levels) in 2003 and the ODA received (in %) of Vietnam in 2005?
Offer a very short reply. -6.64. What is the difference between the ODA received (in %) in Maldives in 2003 and the ODA received (in %) in Vanuatu in 2005?
Ensure brevity in your answer.  -29.08. What is the difference between the ODA received (in %) in Maldives in 2003 and the ODA received (in %) in Vietnam in 2005?
Provide a short and direct response. 2.53. What is the difference between the ODA received (in %) in Vanuatu in 2003 and the ODA received (in %) in Vietnam in 2005?
Offer a terse response. 52.1. What is the difference between the ODA received (in %) of Middle East & North Africa (all income levels) in 2004 and the ODA received (in %) of Maldives in 2005?
Give a very brief answer. -15.4. What is the difference between the ODA received (in %) in Middle East & North Africa (all income levels) in 2004 and the ODA received (in %) in Vanuatu in 2005?
Offer a terse response. -37.94. What is the difference between the ODA received (in %) in Middle East & North Africa (all income levels) in 2004 and the ODA received (in %) in Vietnam in 2005?
Keep it short and to the point. -6.33. What is the difference between the ODA received (in %) in Maldives in 2004 and the ODA received (in %) in Vanuatu in 2005?
Your answer should be very brief. -31.06. What is the difference between the ODA received (in %) of Maldives in 2004 and the ODA received (in %) of Vietnam in 2005?
Offer a very short reply. 0.55. What is the difference between the ODA received (in %) in Vanuatu in 2004 and the ODA received (in %) in Vietnam in 2005?
Offer a very short reply. 35.84. What is the average ODA received (in %) in Middle East & North Africa (all income levels) per year?
Your answer should be very brief. 3.41. What is the average ODA received (in %) in Maldives per year?
Give a very brief answer. 14.39. What is the average ODA received (in %) of Vanuatu per year?
Ensure brevity in your answer.  64.7. What is the average ODA received (in %) of Vietnam per year?
Your answer should be very brief. 13.76. In the year 1998, what is the difference between the ODA received (in %) in Middle East & North Africa (all income levels) and ODA received (in %) in Maldives?
Give a very brief answer. -12.26. In the year 1998, what is the difference between the ODA received (in %) of Middle East & North Africa (all income levels) and ODA received (in %) of Vanuatu?
Make the answer very short. -87.22. In the year 1998, what is the difference between the ODA received (in %) of Middle East & North Africa (all income levels) and ODA received (in %) of Vietnam?
Offer a very short reply. -11.75. In the year 1998, what is the difference between the ODA received (in %) in Maldives and ODA received (in %) in Vanuatu?
Keep it short and to the point. -74.96. In the year 1998, what is the difference between the ODA received (in %) in Maldives and ODA received (in %) in Vietnam?
Offer a very short reply. 0.51. In the year 1998, what is the difference between the ODA received (in %) in Vanuatu and ODA received (in %) in Vietnam?
Provide a succinct answer. 75.47. In the year 1999, what is the difference between the ODA received (in %) in Middle East & North Africa (all income levels) and ODA received (in %) in Maldives?
Ensure brevity in your answer.  -12.76. In the year 1999, what is the difference between the ODA received (in %) of Middle East & North Africa (all income levels) and ODA received (in %) of Vanuatu?
Give a very brief answer. -70.38. In the year 1999, what is the difference between the ODA received (in %) of Middle East & North Africa (all income levels) and ODA received (in %) of Vietnam?
Provide a short and direct response. -15.3. In the year 1999, what is the difference between the ODA received (in %) in Maldives and ODA received (in %) in Vanuatu?
Ensure brevity in your answer.  -57.63. In the year 1999, what is the difference between the ODA received (in %) of Maldives and ODA received (in %) of Vietnam?
Make the answer very short. -2.55. In the year 1999, what is the difference between the ODA received (in %) of Vanuatu and ODA received (in %) of Vietnam?
Make the answer very short. 55.08. In the year 2000, what is the difference between the ODA received (in %) in Middle East & North Africa (all income levels) and ODA received (in %) in Maldives?
Provide a short and direct response. -9.33. In the year 2000, what is the difference between the ODA received (in %) in Middle East & North Africa (all income levels) and ODA received (in %) in Vanuatu?
Ensure brevity in your answer.  -82.23. In the year 2000, what is the difference between the ODA received (in %) of Middle East & North Africa (all income levels) and ODA received (in %) of Vietnam?
Ensure brevity in your answer.  -15.89. In the year 2000, what is the difference between the ODA received (in %) of Maldives and ODA received (in %) of Vanuatu?
Provide a short and direct response. -72.9. In the year 2000, what is the difference between the ODA received (in %) of Maldives and ODA received (in %) of Vietnam?
Your answer should be very brief. -6.56. In the year 2000, what is the difference between the ODA received (in %) of Vanuatu and ODA received (in %) of Vietnam?
Offer a very short reply. 66.33. In the year 2001, what is the difference between the ODA received (in %) in Middle East & North Africa (all income levels) and ODA received (in %) in Maldives?
Your response must be concise. -11.81. In the year 2001, what is the difference between the ODA received (in %) of Middle East & North Africa (all income levels) and ODA received (in %) of Vanuatu?
Provide a succinct answer. -64.68. In the year 2001, what is the difference between the ODA received (in %) in Middle East & North Africa (all income levels) and ODA received (in %) in Vietnam?
Provide a short and direct response. -11.75. In the year 2001, what is the difference between the ODA received (in %) of Maldives and ODA received (in %) of Vanuatu?
Your answer should be very brief. -52.87. In the year 2001, what is the difference between the ODA received (in %) in Maldives and ODA received (in %) in Vietnam?
Provide a succinct answer. 0.06. In the year 2001, what is the difference between the ODA received (in %) in Vanuatu and ODA received (in %) in Vietnam?
Your answer should be compact. 52.93. In the year 2002, what is the difference between the ODA received (in %) of Middle East & North Africa (all income levels) and ODA received (in %) of Maldives?
Your answer should be compact. -14.64. In the year 2002, what is the difference between the ODA received (in %) in Middle East & North Africa (all income levels) and ODA received (in %) in Vanuatu?
Offer a terse response. -51.39. In the year 2002, what is the difference between the ODA received (in %) of Middle East & North Africa (all income levels) and ODA received (in %) of Vietnam?
Keep it short and to the point. -8.84. In the year 2002, what is the difference between the ODA received (in %) in Maldives and ODA received (in %) in Vanuatu?
Give a very brief answer. -36.75. In the year 2002, what is the difference between the ODA received (in %) of Maldives and ODA received (in %) of Vietnam?
Make the answer very short. 5.8. In the year 2002, what is the difference between the ODA received (in %) of Vanuatu and ODA received (in %) of Vietnam?
Give a very brief answer. 42.55. In the year 2003, what is the difference between the ODA received (in %) of Middle East & North Africa (all income levels) and ODA received (in %) of Maldives?
Your answer should be very brief. -9.17. In the year 2003, what is the difference between the ODA received (in %) of Middle East & North Africa (all income levels) and ODA received (in %) of Vanuatu?
Offer a very short reply. -58.74. In the year 2003, what is the difference between the ODA received (in %) in Middle East & North Africa (all income levels) and ODA received (in %) in Vietnam?
Provide a short and direct response. -9.44. In the year 2003, what is the difference between the ODA received (in %) in Maldives and ODA received (in %) in Vanuatu?
Your response must be concise. -49.57. In the year 2003, what is the difference between the ODA received (in %) of Maldives and ODA received (in %) of Vietnam?
Give a very brief answer. -0.27. In the year 2003, what is the difference between the ODA received (in %) of Vanuatu and ODA received (in %) of Vietnam?
Ensure brevity in your answer.  49.3. In the year 2004, what is the difference between the ODA received (in %) in Middle East & North Africa (all income levels) and ODA received (in %) in Maldives?
Your response must be concise. -6.88. In the year 2004, what is the difference between the ODA received (in %) in Middle East & North Africa (all income levels) and ODA received (in %) in Vanuatu?
Ensure brevity in your answer.  -42.17. In the year 2004, what is the difference between the ODA received (in %) of Middle East & North Africa (all income levels) and ODA received (in %) of Vietnam?
Your response must be concise. -7.96. In the year 2004, what is the difference between the ODA received (in %) of Maldives and ODA received (in %) of Vanuatu?
Provide a short and direct response. -35.29. In the year 2004, what is the difference between the ODA received (in %) of Maldives and ODA received (in %) of Vietnam?
Ensure brevity in your answer.  -1.07. In the year 2004, what is the difference between the ODA received (in %) in Vanuatu and ODA received (in %) in Vietnam?
Offer a terse response. 34.21. In the year 2005, what is the difference between the ODA received (in %) of Middle East & North Africa (all income levels) and ODA received (in %) of Maldives?
Provide a short and direct response. -11.01. In the year 2005, what is the difference between the ODA received (in %) in Middle East & North Africa (all income levels) and ODA received (in %) in Vanuatu?
Offer a terse response. -33.55. In the year 2005, what is the difference between the ODA received (in %) of Middle East & North Africa (all income levels) and ODA received (in %) of Vietnam?
Your answer should be compact. -1.94. In the year 2005, what is the difference between the ODA received (in %) of Maldives and ODA received (in %) of Vanuatu?
Provide a succinct answer. -22.54. In the year 2005, what is the difference between the ODA received (in %) in Maldives and ODA received (in %) in Vietnam?
Make the answer very short. 9.07. In the year 2005, what is the difference between the ODA received (in %) of Vanuatu and ODA received (in %) of Vietnam?
Give a very brief answer. 31.61. What is the ratio of the ODA received (in %) in Middle East & North Africa (all income levels) in 1998 to that in 1999?
Ensure brevity in your answer.  1.16. What is the ratio of the ODA received (in %) in Vanuatu in 1998 to that in 1999?
Keep it short and to the point. 1.24. What is the ratio of the ODA received (in %) of Vietnam in 1998 to that in 1999?
Provide a short and direct response. 0.83. What is the ratio of the ODA received (in %) of Middle East & North Africa (all income levels) in 1998 to that in 2000?
Provide a succinct answer. 1.35. What is the ratio of the ODA received (in %) in Maldives in 1998 to that in 2000?
Provide a succinct answer. 1.32. What is the ratio of the ODA received (in %) of Vanuatu in 1998 to that in 2000?
Provide a short and direct response. 1.07. What is the ratio of the ODA received (in %) in Vietnam in 1998 to that in 2000?
Make the answer very short. 0.82. What is the ratio of the ODA received (in %) of Middle East & North Africa (all income levels) in 1998 to that in 2001?
Your response must be concise. 1.37. What is the ratio of the ODA received (in %) in Maldives in 1998 to that in 2001?
Keep it short and to the point. 1.09. What is the ratio of the ODA received (in %) in Vanuatu in 1998 to that in 2001?
Give a very brief answer. 1.35. What is the ratio of the ODA received (in %) of Vietnam in 1998 to that in 2001?
Ensure brevity in your answer.  1.06. What is the ratio of the ODA received (in %) of Middle East & North Africa (all income levels) in 1998 to that in 2002?
Your answer should be compact. 1.46. What is the ratio of the ODA received (in %) of Maldives in 1998 to that in 2002?
Offer a very short reply. 0.92. What is the ratio of the ODA received (in %) in Vanuatu in 1998 to that in 2002?
Provide a short and direct response. 1.69. What is the ratio of the ODA received (in %) in Vietnam in 1998 to that in 2002?
Provide a short and direct response. 1.36. What is the ratio of the ODA received (in %) of Middle East & North Africa (all income levels) in 1998 to that in 2003?
Provide a short and direct response. 0.98. What is the ratio of the ODA received (in %) of Maldives in 1998 to that in 2003?
Provide a succinct answer. 1.25. What is the ratio of the ODA received (in %) of Vanuatu in 1998 to that in 2003?
Give a very brief answer. 1.46. What is the ratio of the ODA received (in %) of Vietnam in 1998 to that in 2003?
Your answer should be very brief. 1.18. What is the ratio of the ODA received (in %) in Middle East & North Africa (all income levels) in 1998 to that in 2004?
Provide a short and direct response. 0.9. What is the ratio of the ODA received (in %) of Maldives in 1998 to that in 2004?
Your response must be concise. 1.48. What is the ratio of the ODA received (in %) in Vanuatu in 1998 to that in 2004?
Give a very brief answer. 1.98. What is the ratio of the ODA received (in %) in Vietnam in 1998 to that in 2004?
Provide a short and direct response. 1.3. What is the ratio of the ODA received (in %) of Middle East & North Africa (all income levels) in 1998 to that in 2005?
Ensure brevity in your answer.  0.4. What is the ratio of the ODA received (in %) of Maldives in 1998 to that in 2005?
Your answer should be compact. 0.81. What is the ratio of the ODA received (in %) in Vanuatu in 1998 to that in 2005?
Your answer should be compact. 2.18. What is the ratio of the ODA received (in %) in Vietnam in 1998 to that in 2005?
Your answer should be compact. 1.51. What is the ratio of the ODA received (in %) in Middle East & North Africa (all income levels) in 1999 to that in 2000?
Keep it short and to the point. 1.17. What is the ratio of the ODA received (in %) in Maldives in 1999 to that in 2000?
Give a very brief answer. 1.33. What is the ratio of the ODA received (in %) of Vanuatu in 1999 to that in 2000?
Offer a terse response. 0.86. What is the ratio of the ODA received (in %) of Middle East & North Africa (all income levels) in 1999 to that in 2001?
Offer a very short reply. 1.18. What is the ratio of the ODA received (in %) of Maldives in 1999 to that in 2001?
Your response must be concise. 1.1. What is the ratio of the ODA received (in %) in Vanuatu in 1999 to that in 2001?
Provide a short and direct response. 1.09. What is the ratio of the ODA received (in %) in Vietnam in 1999 to that in 2001?
Your answer should be compact. 1.28. What is the ratio of the ODA received (in %) in Middle East & North Africa (all income levels) in 1999 to that in 2002?
Provide a short and direct response. 1.27. What is the ratio of the ODA received (in %) in Maldives in 1999 to that in 2002?
Offer a terse response. 0.92. What is the ratio of the ODA received (in %) of Vanuatu in 1999 to that in 2002?
Your response must be concise. 1.37. What is the ratio of the ODA received (in %) in Vietnam in 1999 to that in 2002?
Offer a terse response. 1.64. What is the ratio of the ODA received (in %) in Middle East & North Africa (all income levels) in 1999 to that in 2003?
Your answer should be compact. 0.85. What is the ratio of the ODA received (in %) in Maldives in 1999 to that in 2003?
Provide a succinct answer. 1.25. What is the ratio of the ODA received (in %) in Vanuatu in 1999 to that in 2003?
Offer a very short reply. 1.18. What is the ratio of the ODA received (in %) of Vietnam in 1999 to that in 2003?
Keep it short and to the point. 1.43. What is the ratio of the ODA received (in %) of Middle East & North Africa (all income levels) in 1999 to that in 2004?
Provide a succinct answer. 0.78. What is the ratio of the ODA received (in %) of Maldives in 1999 to that in 2004?
Provide a short and direct response. 1.49. What is the ratio of the ODA received (in %) of Vanuatu in 1999 to that in 2004?
Keep it short and to the point. 1.6. What is the ratio of the ODA received (in %) in Vietnam in 1999 to that in 2004?
Keep it short and to the point. 1.57. What is the ratio of the ODA received (in %) in Middle East & North Africa (all income levels) in 1999 to that in 2005?
Give a very brief answer. 0.34. What is the ratio of the ODA received (in %) in Maldives in 1999 to that in 2005?
Your answer should be very brief. 0.82. What is the ratio of the ODA received (in %) in Vanuatu in 1999 to that in 2005?
Ensure brevity in your answer.  1.76. What is the ratio of the ODA received (in %) in Vietnam in 1999 to that in 2005?
Provide a short and direct response. 1.83. What is the ratio of the ODA received (in %) in Middle East & North Africa (all income levels) in 2000 to that in 2001?
Your answer should be very brief. 1.01. What is the ratio of the ODA received (in %) in Maldives in 2000 to that in 2001?
Keep it short and to the point. 0.83. What is the ratio of the ODA received (in %) of Vanuatu in 2000 to that in 2001?
Provide a succinct answer. 1.26. What is the ratio of the ODA received (in %) in Vietnam in 2000 to that in 2001?
Keep it short and to the point. 1.3. What is the ratio of the ODA received (in %) of Middle East & North Africa (all income levels) in 2000 to that in 2002?
Ensure brevity in your answer.  1.08. What is the ratio of the ODA received (in %) in Maldives in 2000 to that in 2002?
Your answer should be very brief. 0.69. What is the ratio of the ODA received (in %) in Vanuatu in 2000 to that in 2002?
Your response must be concise. 1.58. What is the ratio of the ODA received (in %) in Vietnam in 2000 to that in 2002?
Give a very brief answer. 1.66. What is the ratio of the ODA received (in %) in Middle East & North Africa (all income levels) in 2000 to that in 2003?
Provide a succinct answer. 0.73. What is the ratio of the ODA received (in %) of Maldives in 2000 to that in 2003?
Offer a terse response. 0.94. What is the ratio of the ODA received (in %) of Vanuatu in 2000 to that in 2003?
Your answer should be compact. 1.37. What is the ratio of the ODA received (in %) in Vietnam in 2000 to that in 2003?
Offer a very short reply. 1.44. What is the ratio of the ODA received (in %) of Middle East & North Africa (all income levels) in 2000 to that in 2004?
Provide a succinct answer. 0.66. What is the ratio of the ODA received (in %) of Maldives in 2000 to that in 2004?
Keep it short and to the point. 1.12. What is the ratio of the ODA received (in %) in Vanuatu in 2000 to that in 2004?
Your answer should be compact. 1.85. What is the ratio of the ODA received (in %) of Vietnam in 2000 to that in 2004?
Give a very brief answer. 1.59. What is the ratio of the ODA received (in %) in Middle East & North Africa (all income levels) in 2000 to that in 2005?
Give a very brief answer. 0.29. What is the ratio of the ODA received (in %) of Maldives in 2000 to that in 2005?
Keep it short and to the point. 0.62. What is the ratio of the ODA received (in %) in Vanuatu in 2000 to that in 2005?
Your response must be concise. 2.04. What is the ratio of the ODA received (in %) of Vietnam in 2000 to that in 2005?
Your answer should be compact. 1.85. What is the ratio of the ODA received (in %) in Middle East & North Africa (all income levels) in 2001 to that in 2002?
Your answer should be very brief. 1.07. What is the ratio of the ODA received (in %) of Maldives in 2001 to that in 2002?
Ensure brevity in your answer.  0.84. What is the ratio of the ODA received (in %) of Vanuatu in 2001 to that in 2002?
Provide a succinct answer. 1.25. What is the ratio of the ODA received (in %) in Vietnam in 2001 to that in 2002?
Ensure brevity in your answer.  1.28. What is the ratio of the ODA received (in %) of Middle East & North Africa (all income levels) in 2001 to that in 2003?
Your answer should be very brief. 0.72. What is the ratio of the ODA received (in %) of Maldives in 2001 to that in 2003?
Offer a very short reply. 1.14. What is the ratio of the ODA received (in %) of Vanuatu in 2001 to that in 2003?
Provide a short and direct response. 1.08. What is the ratio of the ODA received (in %) of Vietnam in 2001 to that in 2003?
Make the answer very short. 1.11. What is the ratio of the ODA received (in %) in Middle East & North Africa (all income levels) in 2001 to that in 2004?
Ensure brevity in your answer.  0.66. What is the ratio of the ODA received (in %) in Maldives in 2001 to that in 2004?
Your response must be concise. 1.36. What is the ratio of the ODA received (in %) of Vanuatu in 2001 to that in 2004?
Your response must be concise. 1.47. What is the ratio of the ODA received (in %) in Vietnam in 2001 to that in 2004?
Make the answer very short. 1.23. What is the ratio of the ODA received (in %) in Middle East & North Africa (all income levels) in 2001 to that in 2005?
Ensure brevity in your answer.  0.29. What is the ratio of the ODA received (in %) of Maldives in 2001 to that in 2005?
Your response must be concise. 0.75. What is the ratio of the ODA received (in %) in Vanuatu in 2001 to that in 2005?
Provide a succinct answer. 1.62. What is the ratio of the ODA received (in %) in Vietnam in 2001 to that in 2005?
Make the answer very short. 1.43. What is the ratio of the ODA received (in %) of Middle East & North Africa (all income levels) in 2002 to that in 2003?
Ensure brevity in your answer.  0.67. What is the ratio of the ODA received (in %) in Maldives in 2002 to that in 2003?
Your answer should be compact. 1.36. What is the ratio of the ODA received (in %) in Vanuatu in 2002 to that in 2003?
Provide a succinct answer. 0.86. What is the ratio of the ODA received (in %) of Vietnam in 2002 to that in 2003?
Your response must be concise. 0.87. What is the ratio of the ODA received (in %) of Middle East & North Africa (all income levels) in 2002 to that in 2004?
Ensure brevity in your answer.  0.61. What is the ratio of the ODA received (in %) of Maldives in 2002 to that in 2004?
Offer a very short reply. 1.62. What is the ratio of the ODA received (in %) of Vanuatu in 2002 to that in 2004?
Your answer should be compact. 1.17. What is the ratio of the ODA received (in %) in Vietnam in 2002 to that in 2004?
Offer a very short reply. 0.96. What is the ratio of the ODA received (in %) of Middle East & North Africa (all income levels) in 2002 to that in 2005?
Give a very brief answer. 0.27. What is the ratio of the ODA received (in %) in Maldives in 2002 to that in 2005?
Your answer should be very brief. 0.89. What is the ratio of the ODA received (in %) of Vanuatu in 2002 to that in 2005?
Offer a terse response. 1.29. What is the ratio of the ODA received (in %) in Vietnam in 2002 to that in 2005?
Give a very brief answer. 1.12. What is the ratio of the ODA received (in %) of Middle East & North Africa (all income levels) in 2003 to that in 2004?
Keep it short and to the point. 0.91. What is the ratio of the ODA received (in %) of Maldives in 2003 to that in 2004?
Offer a terse response. 1.19. What is the ratio of the ODA received (in %) of Vanuatu in 2003 to that in 2004?
Offer a very short reply. 1.36. What is the ratio of the ODA received (in %) in Vietnam in 2003 to that in 2004?
Make the answer very short. 1.1. What is the ratio of the ODA received (in %) of Middle East & North Africa (all income levels) in 2003 to that in 2005?
Your answer should be compact. 0.41. What is the ratio of the ODA received (in %) of Maldives in 2003 to that in 2005?
Make the answer very short. 0.65. What is the ratio of the ODA received (in %) of Vanuatu in 2003 to that in 2005?
Make the answer very short. 1.49. What is the ratio of the ODA received (in %) of Vietnam in 2003 to that in 2005?
Make the answer very short. 1.29. What is the ratio of the ODA received (in %) of Middle East & North Africa (all income levels) in 2004 to that in 2005?
Your response must be concise. 0.44. What is the ratio of the ODA received (in %) of Maldives in 2004 to that in 2005?
Your answer should be compact. 0.55. What is the ratio of the ODA received (in %) in Vanuatu in 2004 to that in 2005?
Make the answer very short. 1.1. What is the ratio of the ODA received (in %) in Vietnam in 2004 to that in 2005?
Make the answer very short. 1.17. What is the difference between the highest and the second highest ODA received (in %) of Middle East & North Africa (all income levels)?
Provide a short and direct response. 4.39. What is the difference between the highest and the second highest ODA received (in %) of Maldives?
Ensure brevity in your answer.  2.11. What is the difference between the highest and the second highest ODA received (in %) of Vanuatu?
Your answer should be very brief. 5.81. What is the difference between the highest and the second highest ODA received (in %) in Vietnam?
Make the answer very short. 0.19. What is the difference between the highest and the lowest ODA received (in %) of Middle East & North Africa (all income levels)?
Ensure brevity in your answer.  5.74. What is the difference between the highest and the lowest ODA received (in %) of Maldives?
Keep it short and to the point. 8.52. What is the difference between the highest and the lowest ODA received (in %) in Vanuatu?
Provide a succinct answer. 48.92. What is the difference between the highest and the lowest ODA received (in %) in Vietnam?
Ensure brevity in your answer.  8.38. 